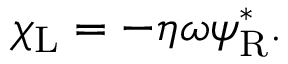<formula> <loc_0><loc_0><loc_500><loc_500>\chi _ { L } = - \eta \omega \psi _ { R } ^ { * } .</formula> 